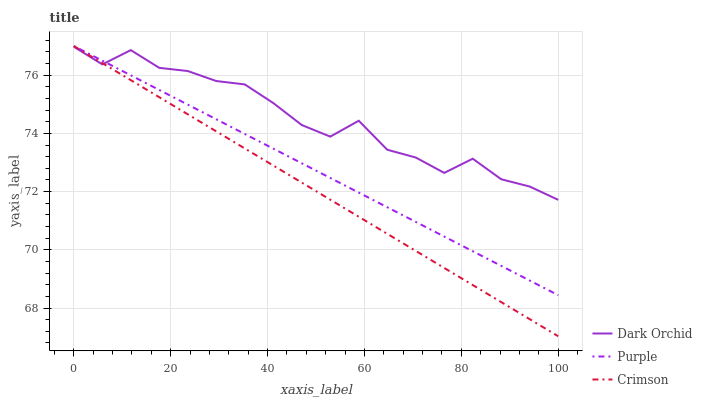Does Crimson have the minimum area under the curve?
Answer yes or no. Yes. Does Dark Orchid have the maximum area under the curve?
Answer yes or no. Yes. Does Dark Orchid have the minimum area under the curve?
Answer yes or no. No. Does Crimson have the maximum area under the curve?
Answer yes or no. No. Is Crimson the smoothest?
Answer yes or no. Yes. Is Dark Orchid the roughest?
Answer yes or no. Yes. Is Dark Orchid the smoothest?
Answer yes or no. No. Is Crimson the roughest?
Answer yes or no. No. Does Crimson have the lowest value?
Answer yes or no. Yes. Does Dark Orchid have the lowest value?
Answer yes or no. No. Does Crimson have the highest value?
Answer yes or no. Yes. Does Dark Orchid have the highest value?
Answer yes or no. No. Does Dark Orchid intersect Crimson?
Answer yes or no. Yes. Is Dark Orchid less than Crimson?
Answer yes or no. No. Is Dark Orchid greater than Crimson?
Answer yes or no. No. 